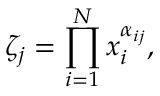<formula> <loc_0><loc_0><loc_500><loc_500>\zeta _ { j } = \prod _ { i = 1 } ^ { N } x _ { i } ^ { \alpha _ { i j } } ,</formula> 